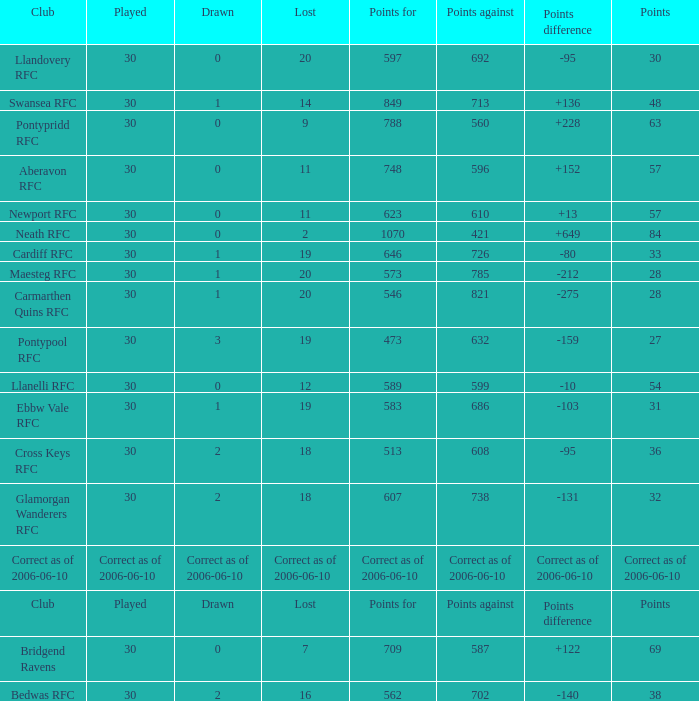What is Points, when Points For is "562"? 38.0. 